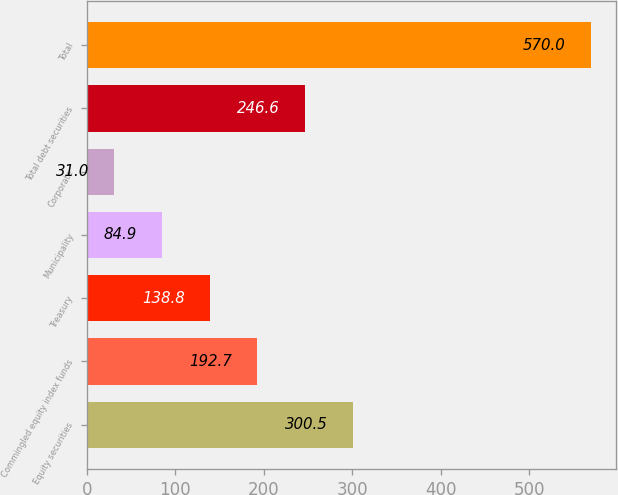<chart> <loc_0><loc_0><loc_500><loc_500><bar_chart><fcel>Equity securities<fcel>Commingled equity index funds<fcel>Treasury<fcel>Municipality<fcel>Corporate<fcel>Total debt securities<fcel>Total<nl><fcel>300.5<fcel>192.7<fcel>138.8<fcel>84.9<fcel>31<fcel>246.6<fcel>570<nl></chart> 